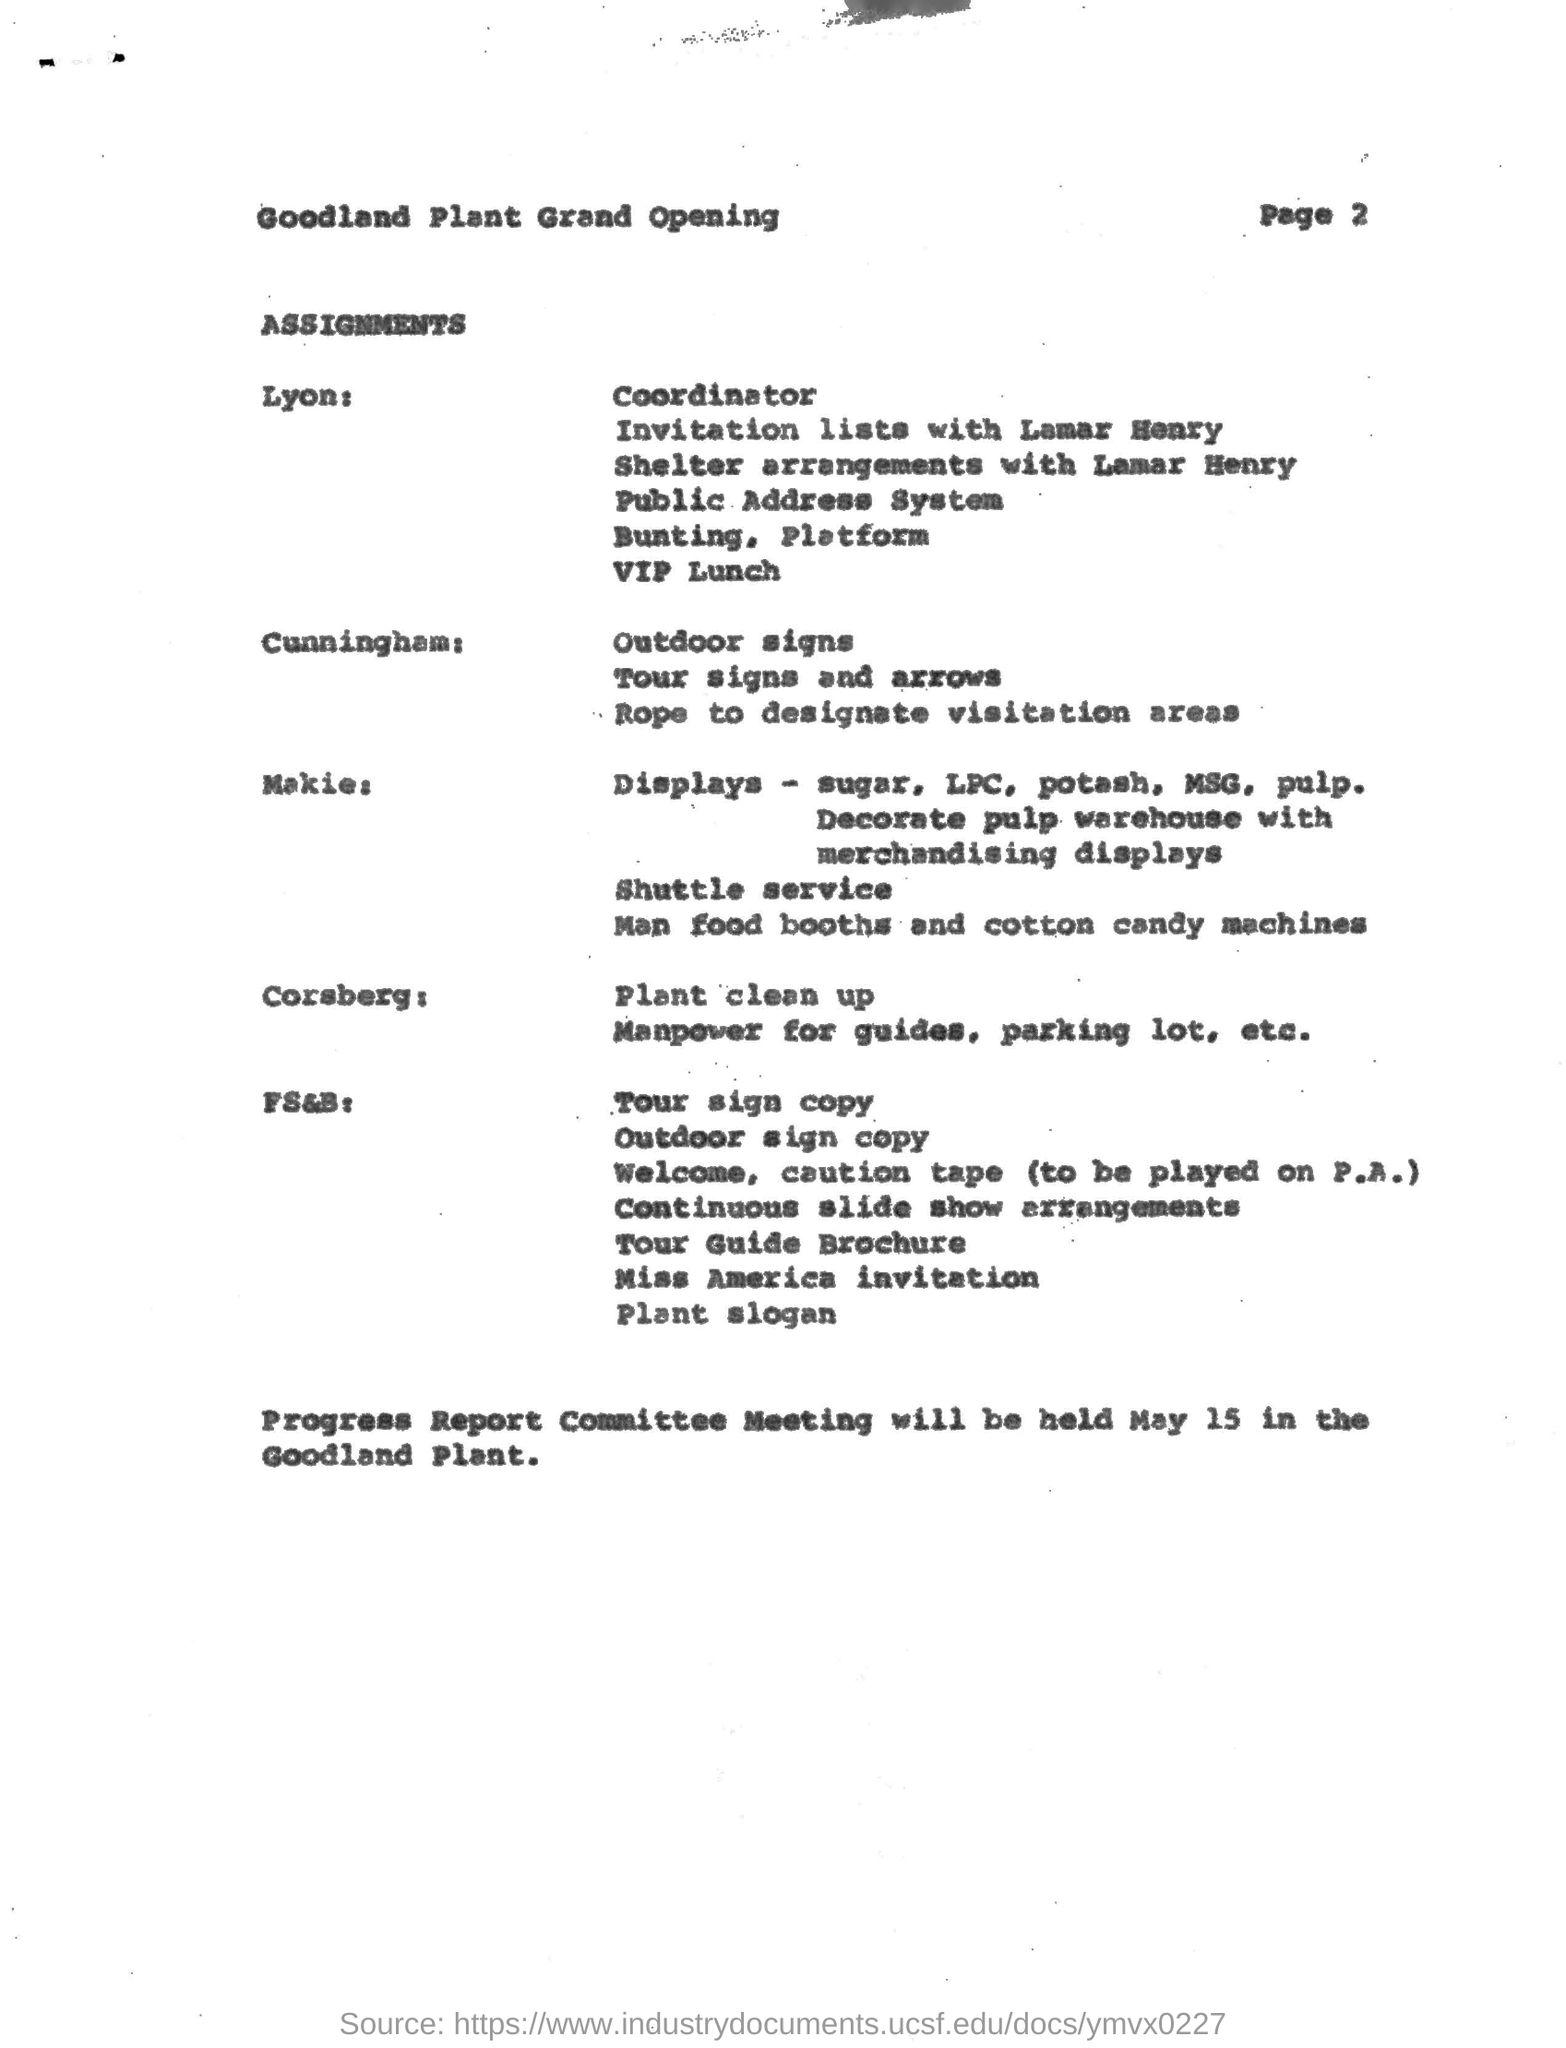Draw attention to some important aspects in this diagram. The speaker is announcing that they are in possession of the assignment related to plant clean up, and their name is Corsberg. The progress report committee meeting will be held at the Goodland Plant. I, Cunningham, am in possession of the assignment for "Outdoor Signs." 